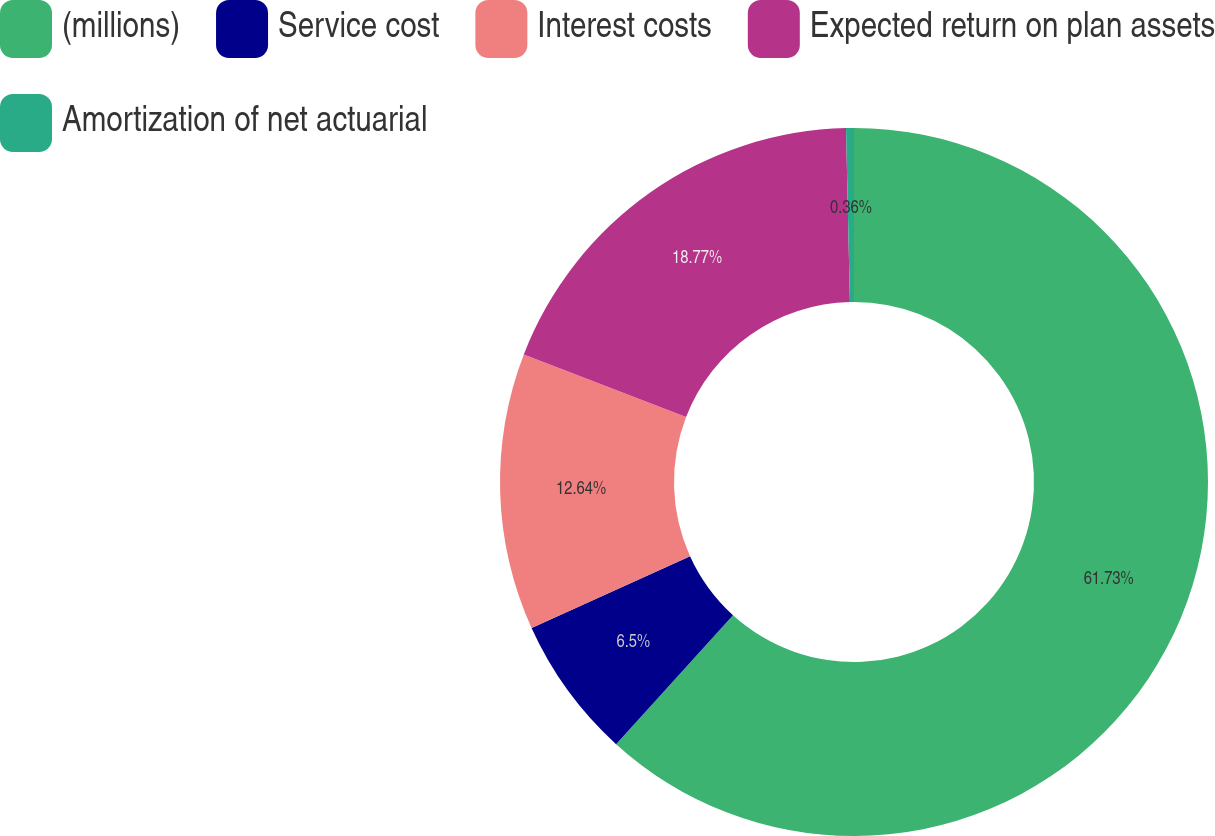Convert chart to OTSL. <chart><loc_0><loc_0><loc_500><loc_500><pie_chart><fcel>(millions)<fcel>Service cost<fcel>Interest costs<fcel>Expected return on plan assets<fcel>Amortization of net actuarial<nl><fcel>61.73%<fcel>6.5%<fcel>12.64%<fcel>18.77%<fcel>0.36%<nl></chart> 